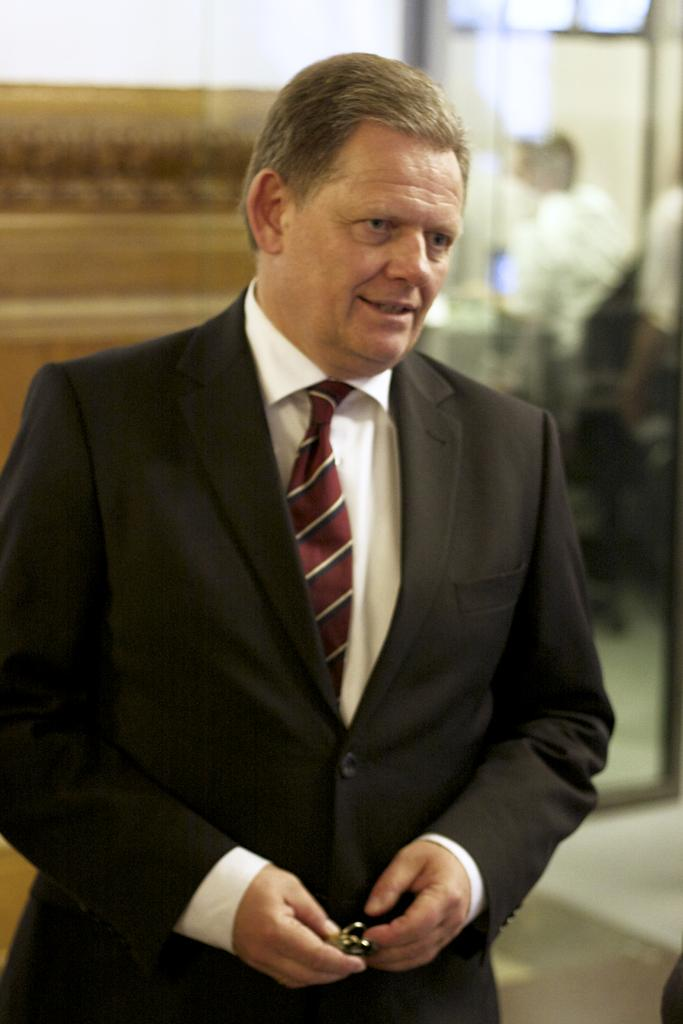How many people are in the image? There is a group of people in the image, but the exact number is not specified. What can be seen in the background of the image? There is a wall in the background of the image, along with some other unspecified items. What type of whip is being used by the expert in the image? There is no whip or expert present in the image. 